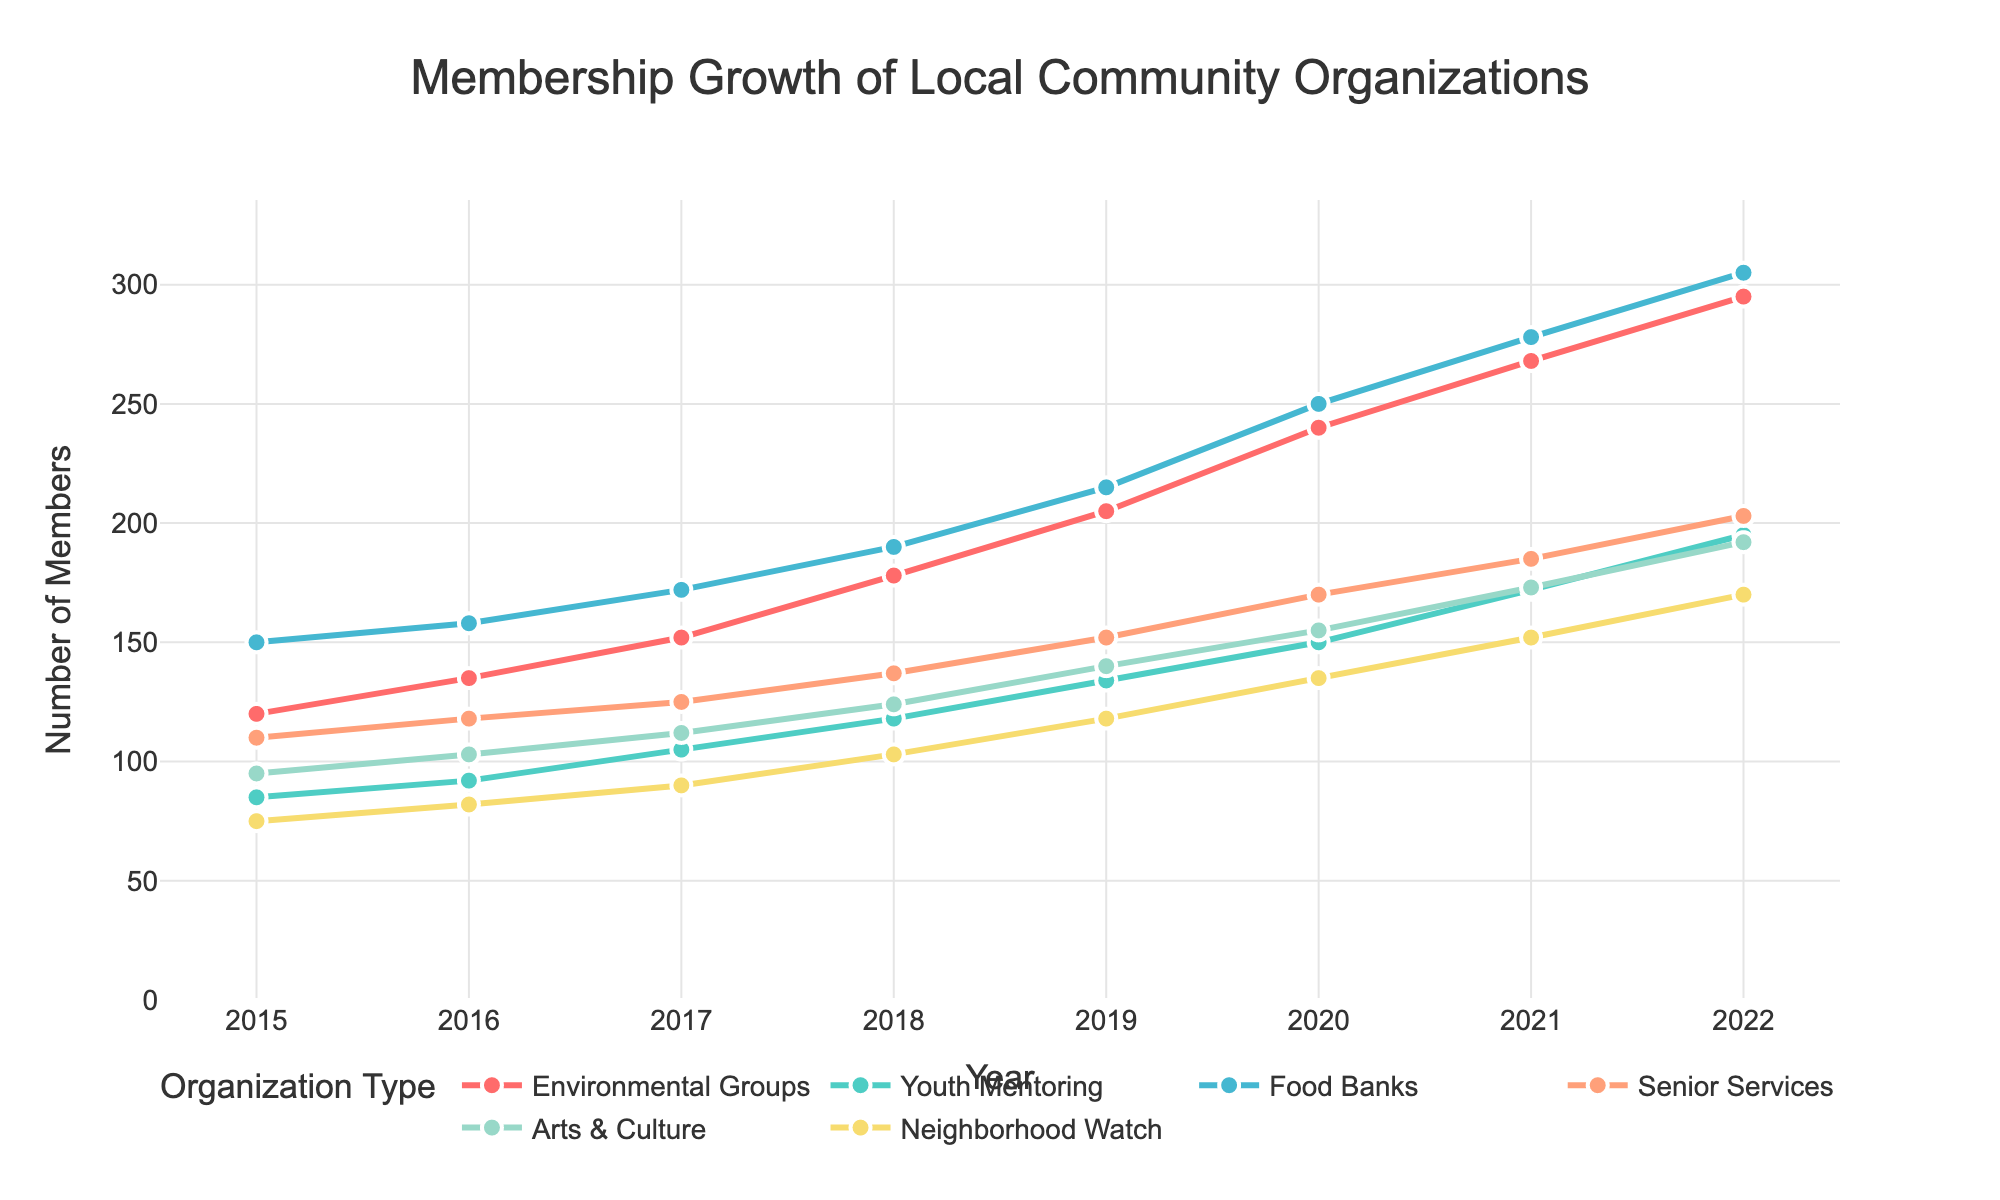Which organization type had the highest membership growth in 2022? Look at the values for each organization in 2022. The Environmental Groups had 295 members, which is the highest among all categories.
Answer: Environmental Groups By how much did the membership of Youth Mentoring increase from 2015 to 2020? Youth Mentoring had 85 members in 2015 and 150 members in 2020. Their membership increased by (150 - 85) = 65 members over this period.
Answer: 65 Which organization had the smallest membership in 2019? Look at the 2019 values for each organization. Neighborhood Watch had 118 members, which is the smallest among all categories.
Answer: Neighborhood Watch In which year did Food Banks see the largest increase in membership? Calculate the differences in Food Banks membership between consecutive years and compare. From 2019 to 2020, there was an increase of (250 - 215) = 35 members, which is the largest increase.
Answer: 2020 How many total members were there across all groups in 2017? Sum the memberships of all groups in 2017: 152 (Environmental Groups) + 105 (Youth Mentoring) + 172 (Food Banks) + 125 (Senior Services) + 112 (Arts & Culture) + 90 (Neighborhood Watch) = 756 members.
Answer: 756 Which organization had the maximum member growth rate between 2015 and 2022? Calculate the growth rate for each organization by ((members in 2022 - members in 2015) / members in 2015). The Environmental Groups had the highest growth rate: ((295 - 120) / 120) × 100 = 145.83%.
Answer: Environmental Groups What was the difference in membership between Senior Services and Arts & Culture in 2021? In 2021, Senior Services had 185 members and Arts & Culture had 173 members. The difference is (185 - 173) = 12 members.
Answer: 12 Which two organizations had nearly equal memberships in 2022? Compare the 2022 memberships. Youth Mentoring had 195 members and Senior Services had 203 members, which are close to each other.
Answer: Youth Mentoring and Senior Services By how many members did Neighborhood Watch grow from 2016 to 2022? Neighborhood Watch had 82 members in 2016 and 170 members in 2022. The growth is (170 - 82) = 88 members.
Answer: 88 What color represents the Environmental Groups in the plot? Look at the color used for the Environmental Groups' line and markers. The Environmental Groups' line is in red.
Answer: Red 